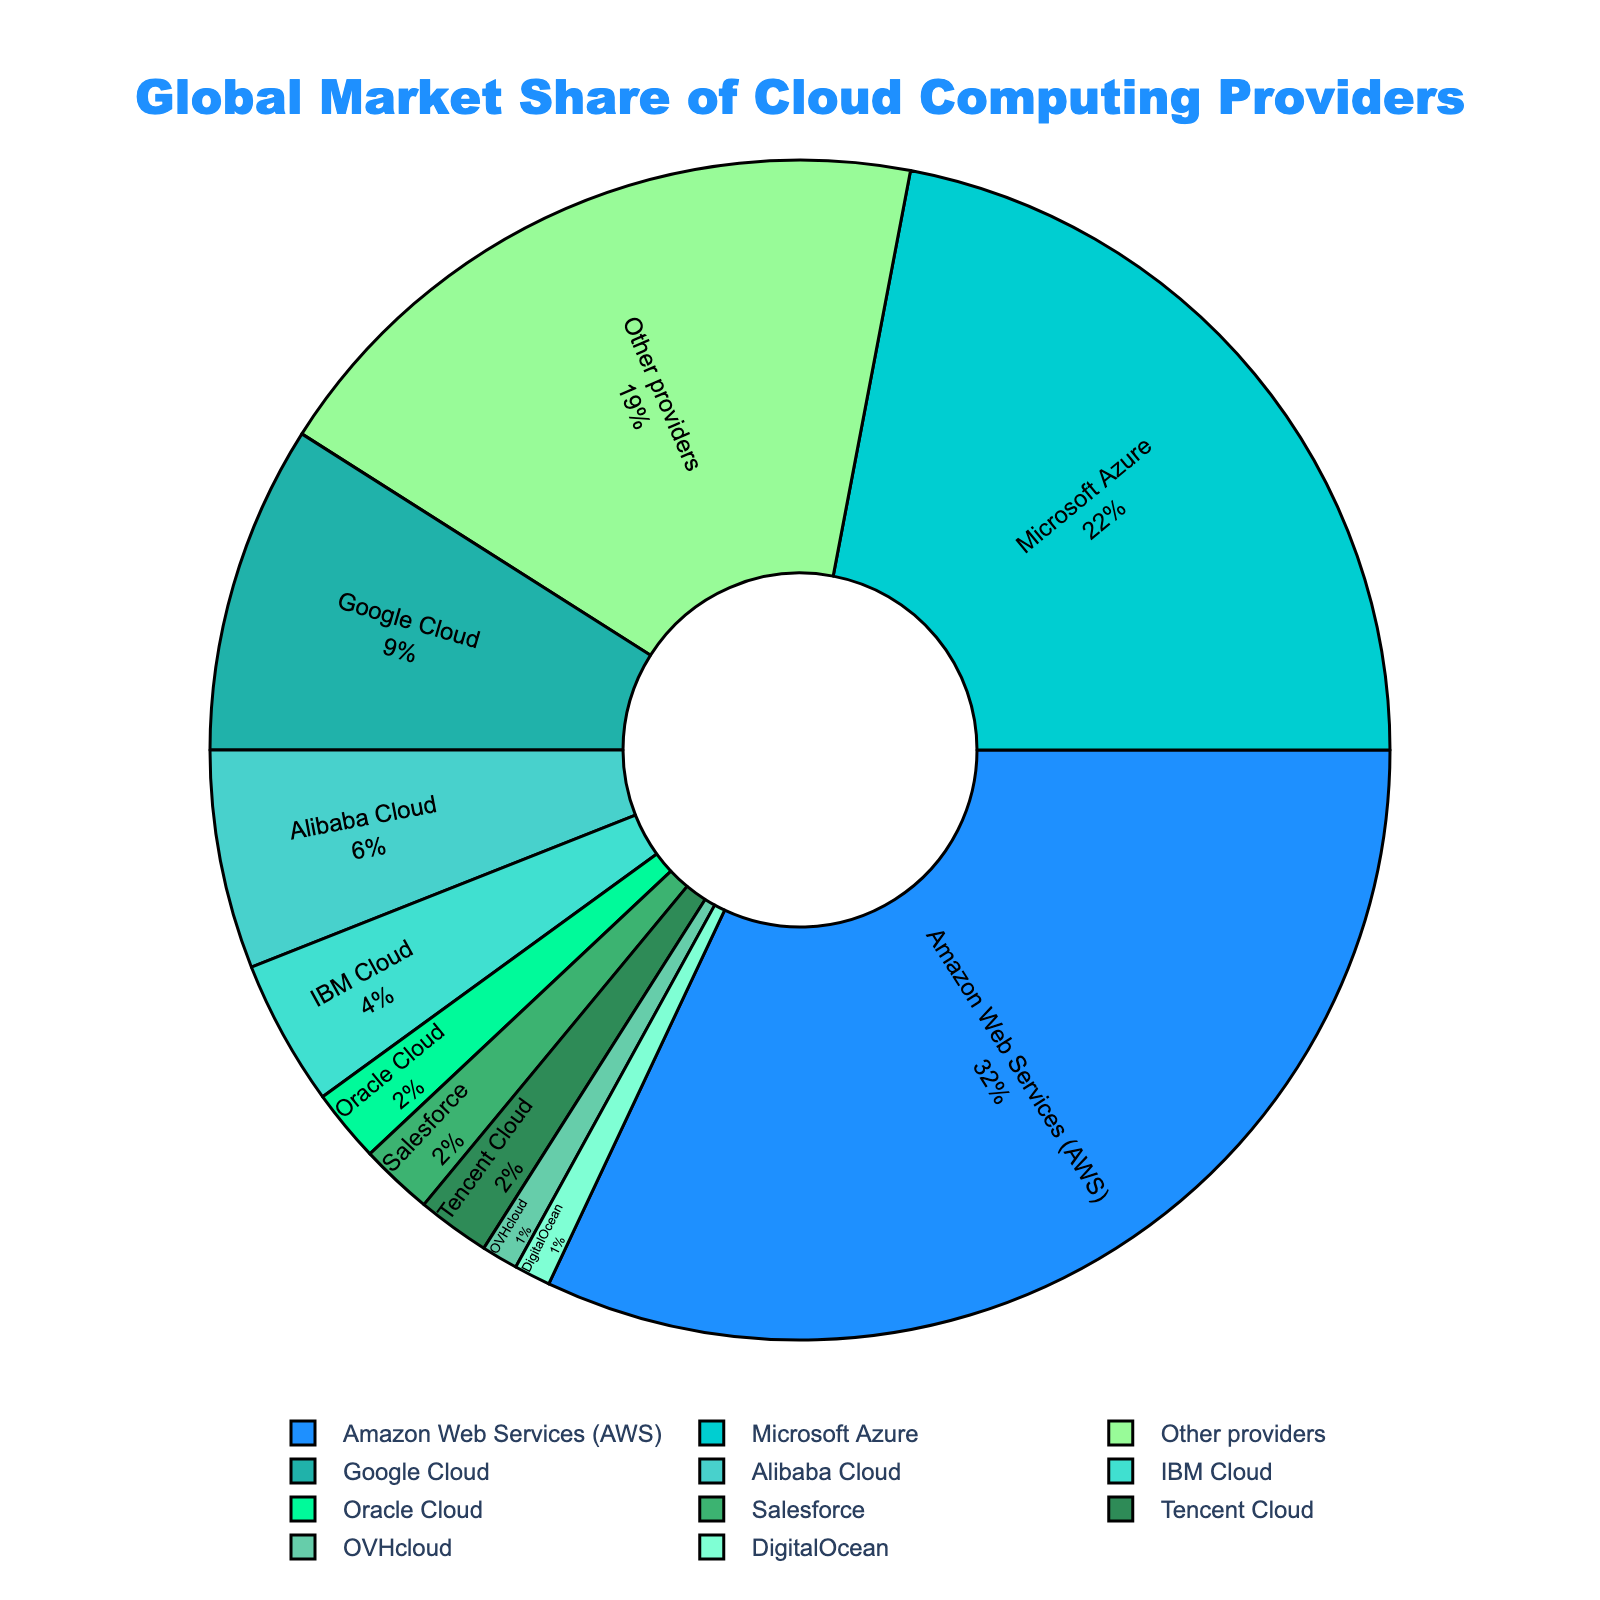What's the largest market share percentage, and which provider does it belong to? The largest percentage can be directly identified from the chart. Amazon Web Services (AWS) has the largest market share at 32%.
Answer: Amazon Web Services (AWS) at 32% What is the combined market share of IBM Cloud and Oracle Cloud? Add the market shares of IBM Cloud (4%) and Oracle Cloud (2%). 4% + 2% = 6%
Answer: 6% Which provider has a smaller market share: Google Cloud or Alibaba Cloud? Compare the market shares of Google Cloud (9%) and Alibaba Cloud (6%). 9% is greater than 6%, so Alibaba Cloud has the smaller market share.
Answer: Alibaba Cloud What is the total market share of providers with individual shares of 2% or less? Sum the market shares of Oracle Cloud (2%), Salesforce (2%), Tencent Cloud (2%), OVHcloud (1%), and DigitalOcean (1%). 2% + 2% + 2% + 1% + 1% = 8%
Answer: 8% Which provider follows Microsoft Azure in terms of market share? Identify the providers by descending market share. Amazon Web Services (AWS) is first, Microsoft Azure is second with 22%, and Google Cloud follows with 9%.
Answer: Google Cloud How much larger is the market share of Amazon Web Services (AWS) compared to Microsoft Azure? Subtract Microsoft's market share from Amazon's. 32% - 22% = 10%
Answer: 10% What percentage of the market is held by providers other than the top three (AWS, Microsoft Azure, Google Cloud)? Sum the market shares of "Other providers" (19%) and the remaining individual shares: Alibaba Cloud (6%), IBM Cloud (4%), Oracle Cloud (2%), Salesforce (2%), Tencent Cloud (2%), OVHcloud (1%), DigitalOcean (1%). Combine these: 19% + 6% + 4% + 2% + 2% + 2% + 1% + 1% = 37%
Answer: 37% What proportion of the market do AWS and Microsoft Azure together form? Add AWS's 32% and Microsoft Azure's 22%. 32% + 22% = 54%
Answer: 54% Among the providers listed, how many have a market share of 2%? Count the providers with a market share of 2%: Oracle Cloud, Salesforce, Tencent Cloud. There are 3 such providers.
Answer: 3 Which segment is displayed with the color used for the provider with precisely 1% market share? Identify the segments marked for OVHcloud and DigitalOcean, both have 1% market share. These segments are colored distinctively.
Answer: OVHcloud, DigitalOcean 